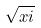<formula> <loc_0><loc_0><loc_500><loc_500>\sqrt { x i }</formula> 